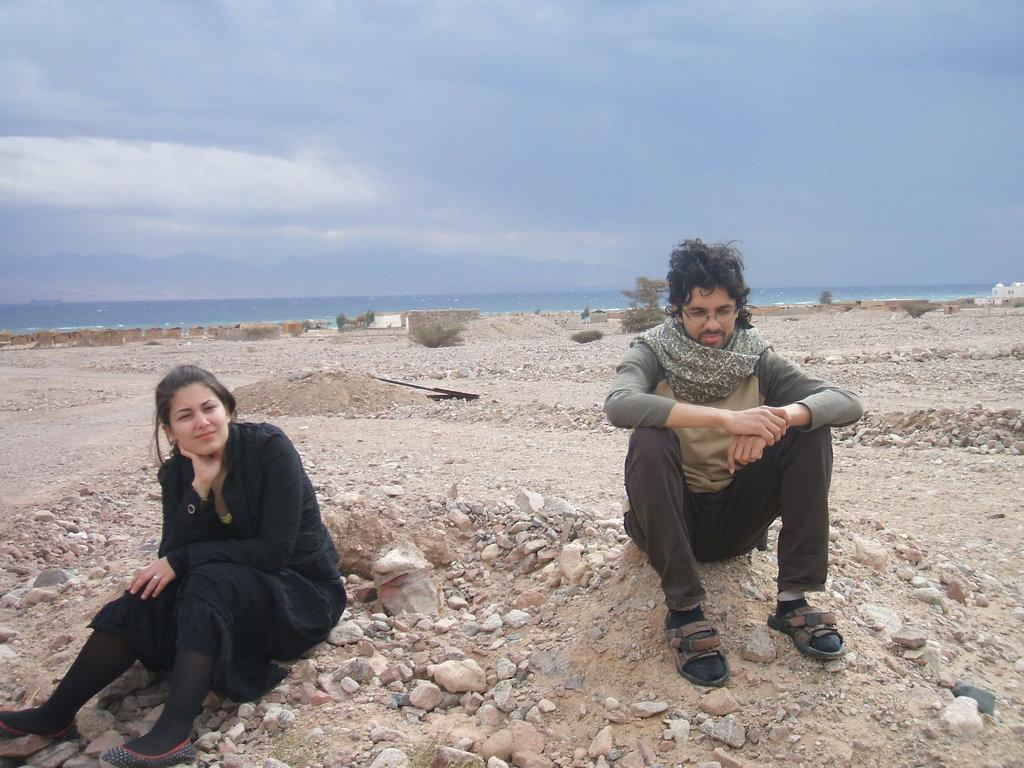Who is present in the image? There is a person and a lady in the image. What are the person and the lady doing in the image? Both the person and the lady are sitting on a surface. What can be seen in the background of the image? There is a river and the sky visible in the background of the image. How many frogs are sitting on the chair in the image? There is no chair or frogs present in the image. What act are the person and the lady performing in the image? The image does not depict any specific act; it simply shows the person and the lady sitting on a surface. 